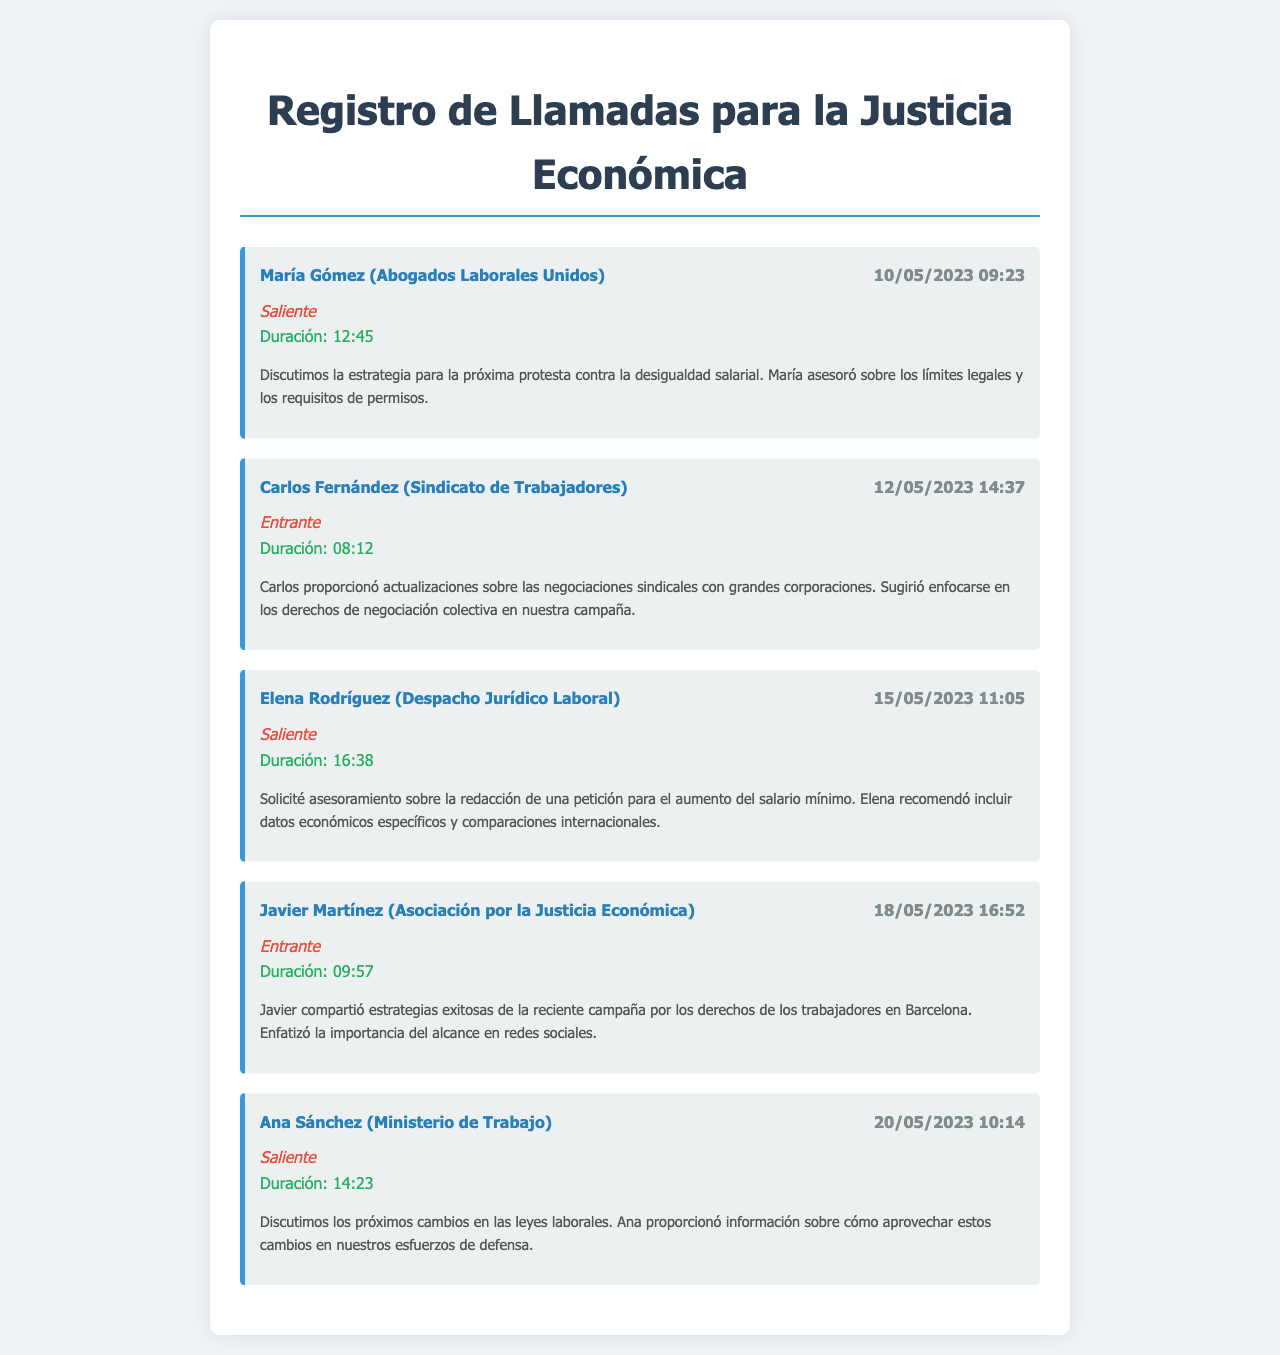¿Cuál es el nombre de la primera contactada? La primera persona contactada en el documento es María Gómez.
Answer: María Gómez ¿Cuál es la duración de la llamada con Carlos Fernández? La duración de la llamada con Carlos Fernández fue de 08:12.
Answer: 08:12 ¿Qué estrategia discutió María Gómez? María discutió la estrategia para la próxima protesta contra la desigualdad salarial.
Answer: protesta contra la desigualdad salarial ¿Qué recomendó Elena Rodríguez incluir en la petición? Elena recomendó incluir datos económicos específicos y comparaciones internacionales en la petición.
Answer: datos económicos específicos y comparaciones internacionales ¿Cuál es el tema de la llamada con Ana Sánchez? La llamada con Ana Sánchez trató sobre los próximos cambios en las leyes laborales.
Answer: próximos cambios en las leyes laborales 